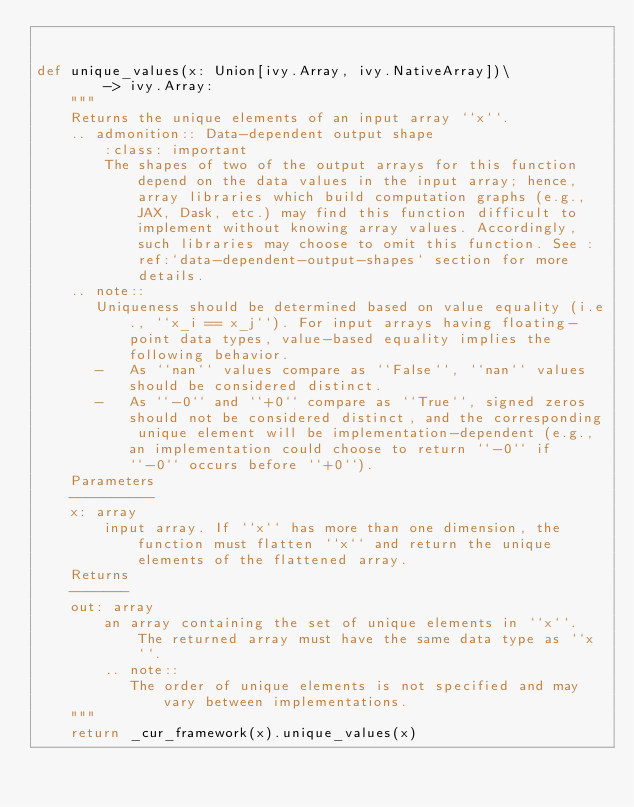<code> <loc_0><loc_0><loc_500><loc_500><_Python_>

def unique_values(x: Union[ivy.Array, ivy.NativeArray])\
        -> ivy.Array:
    """
    Returns the unique elements of an input array ``x``.
    .. admonition:: Data-dependent output shape
        :class: important
        The shapes of two of the output arrays for this function depend on the data values in the input array; hence, array libraries which build computation graphs (e.g., JAX, Dask, etc.) may find this function difficult to implement without knowing array values. Accordingly, such libraries may choose to omit this function. See :ref:`data-dependent-output-shapes` section for more details.
    .. note::
       Uniqueness should be determined based on value equality (i.e., ``x_i == x_j``). For input arrays having floating-point data types, value-based equality implies the following behavior.
       -   As ``nan`` values compare as ``False``, ``nan`` values should be considered distinct.
       -   As ``-0`` and ``+0`` compare as ``True``, signed zeros should not be considered distinct, and the corresponding unique element will be implementation-dependent (e.g., an implementation could choose to return ``-0`` if ``-0`` occurs before ``+0``).
    Parameters
    ----------
    x: array
        input array. If ``x`` has more than one dimension, the function must flatten ``x`` and return the unique elements of the flattened array.
    Returns
    -------
    out: array
        an array containing the set of unique elements in ``x``. The returned array must have the same data type as ``x``.
        .. note::
           The order of unique elements is not specified and may vary between implementations.
    """
    return _cur_framework(x).unique_values(x)
</code> 